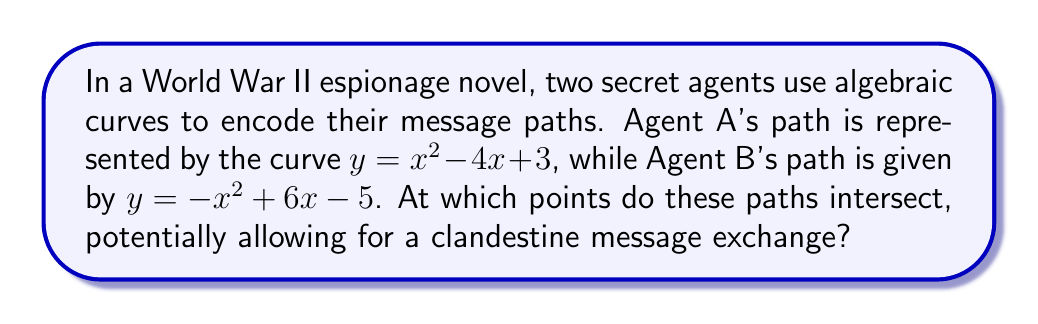Can you solve this math problem? To find the intersection points of these two curves, we need to solve the system of equations:

$$\begin{cases}
y = x^2 - 4x + 3 \\
y = -x^2 + 6x - 5
\end{cases}$$

Step 1: Set the equations equal to each other:
$x^2 - 4x + 3 = -x^2 + 6x - 5$

Step 2: Rearrange all terms to one side:
$2x^2 - 10x + 8 = 0$

Step 3: Divide all terms by 2 to simplify:
$x^2 - 5x + 4 = 0$

Step 4: Use the quadratic formula to solve for x:
$x = \frac{-b \pm \sqrt{b^2 - 4ac}}{2a}$, where $a=1$, $b=-5$, and $c=4$

$x = \frac{5 \pm \sqrt{25 - 16}}{2} = \frac{5 \pm 3}{2}$

Step 5: Solve for the two x-values:
$x_1 = \frac{5 + 3}{2} = 4$ and $x_2 = \frac{5 - 3}{2} = 1$

Step 6: Find the corresponding y-values by substituting x into either original equation:
For $x_1 = 4$: $y = 4^2 - 4(4) + 3 = 16 - 16 + 3 = 3$
For $x_2 = 1$: $y = 1^2 - 4(1) + 3 = 1 - 4 + 3 = 0$

Therefore, the intersection points are (4, 3) and (1, 0).
Answer: (4, 3) and (1, 0) 